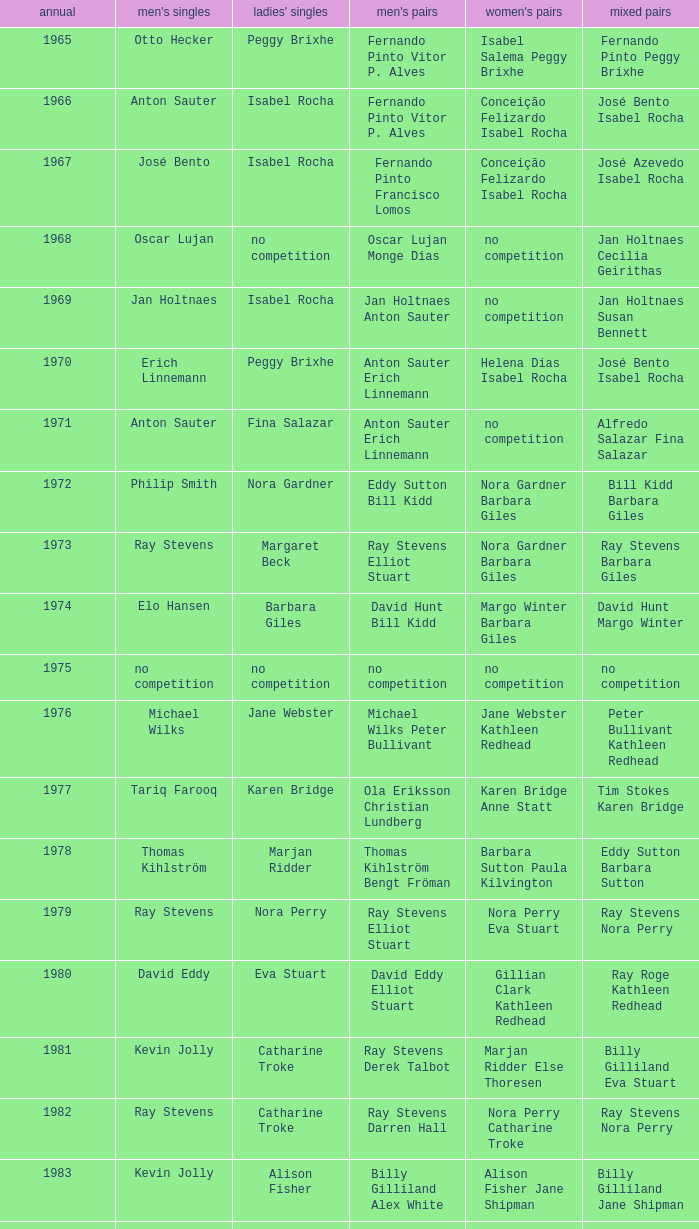What is the average year with alfredo salazar fina salazar in mixed doubles? 1971.0. 